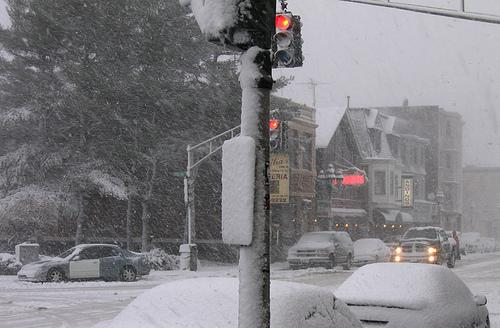Question: why are the cars covered?
Choices:
A. Snow.
B. It's raining.
C. Keep the car cool in the heat.
D. Avoid bird droppings.
Answer with the letter. Answer: A Question: what is the color of the traffic light?
Choices:
A. Green.
B. Red.
C. Yellow.
D. Black.
Answer with the letter. Answer: B Question: when was this picture taken?
Choices:
A. Summer.
B. Fall.
C. Winter.
D. During a rainstorm.
Answer with the letter. Answer: C Question: where are the trees?
Choices:
A. On the far right.
B. In the background.
C. Left side, next to the buildings.
D. In the middle of the photo.
Answer with the letter. Answer: C Question: how many vehicles are in the picture?
Choices:
A. Five.
B. Four.
C. Seven.
D. Six.
Answer with the letter. Answer: D 